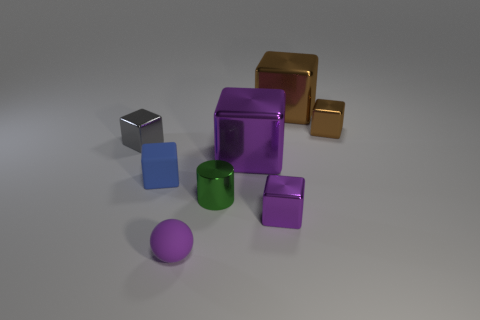Subtract all purple shiny blocks. How many blocks are left? 4 Subtract all purple blocks. How many blocks are left? 4 Subtract all blocks. How many objects are left? 2 Add 2 small brown metal blocks. How many objects exist? 10 Subtract all red spheres. Subtract all green blocks. How many spheres are left? 1 Subtract all gray balls. How many purple blocks are left? 2 Subtract all big brown metal things. Subtract all purple metallic cubes. How many objects are left? 5 Add 6 blue blocks. How many blue blocks are left? 7 Add 1 brown things. How many brown things exist? 3 Subtract 0 blue balls. How many objects are left? 8 